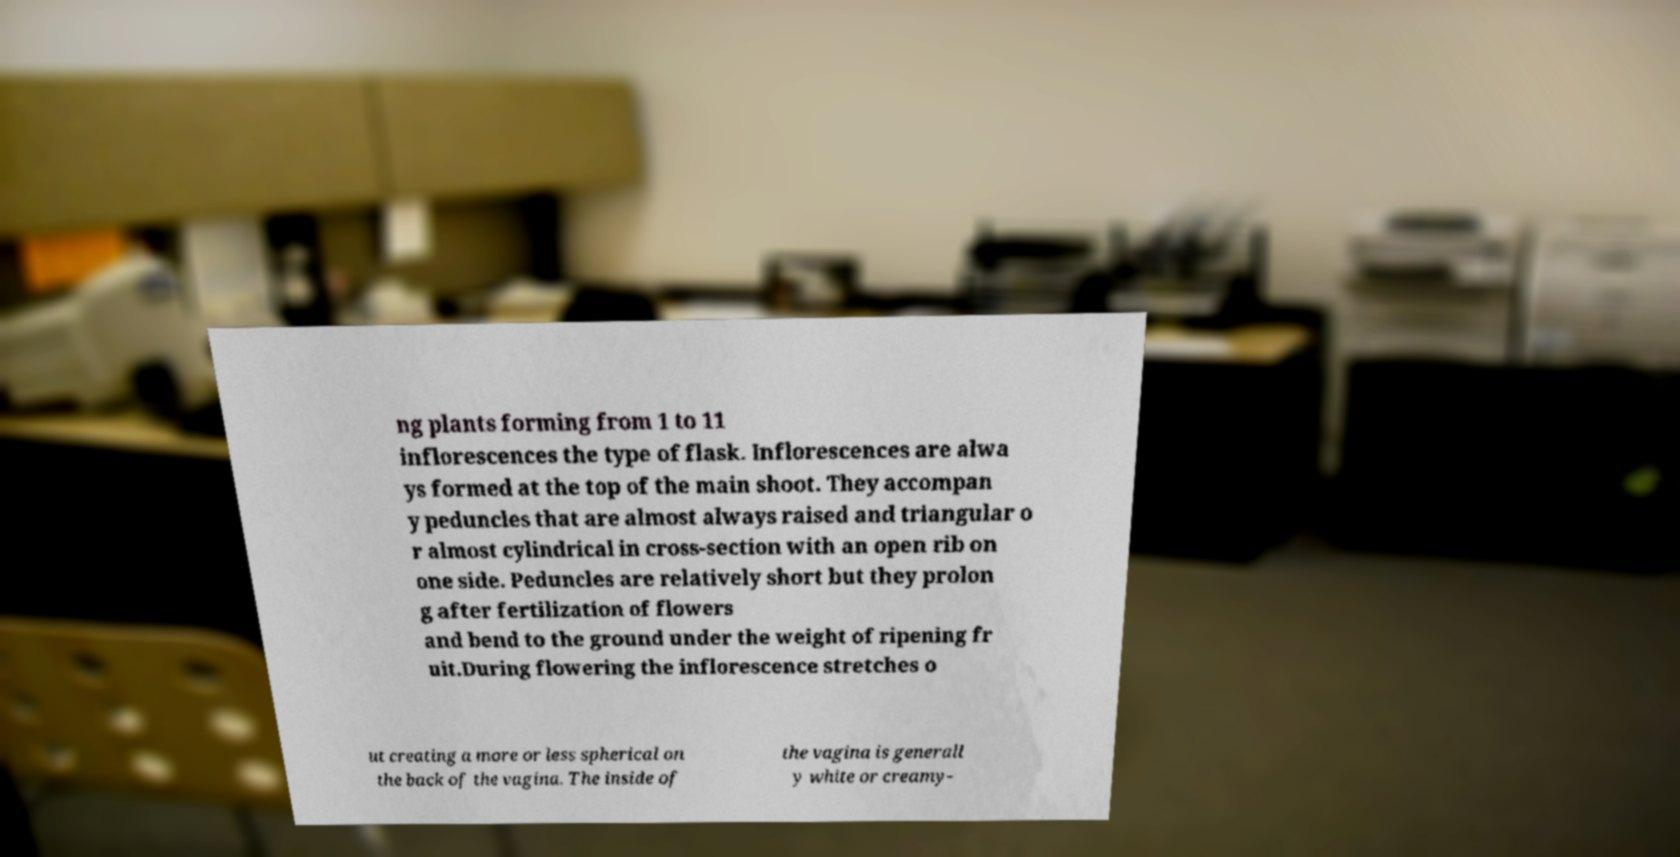Can you read and provide the text displayed in the image?This photo seems to have some interesting text. Can you extract and type it out for me? ng plants forming from 1 to 11 inflorescences the type of flask. Inflorescences are alwa ys formed at the top of the main shoot. They accompan y peduncles that are almost always raised and triangular o r almost cylindrical in cross-section with an open rib on one side. Peduncles are relatively short but they prolon g after fertilization of flowers and bend to the ground under the weight of ripening fr uit.During flowering the inflorescence stretches o ut creating a more or less spherical on the back of the vagina. The inside of the vagina is generall y white or creamy- 